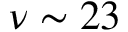Convert formula to latex. <formula><loc_0><loc_0><loc_500><loc_500>\nu \sim 2 3</formula> 